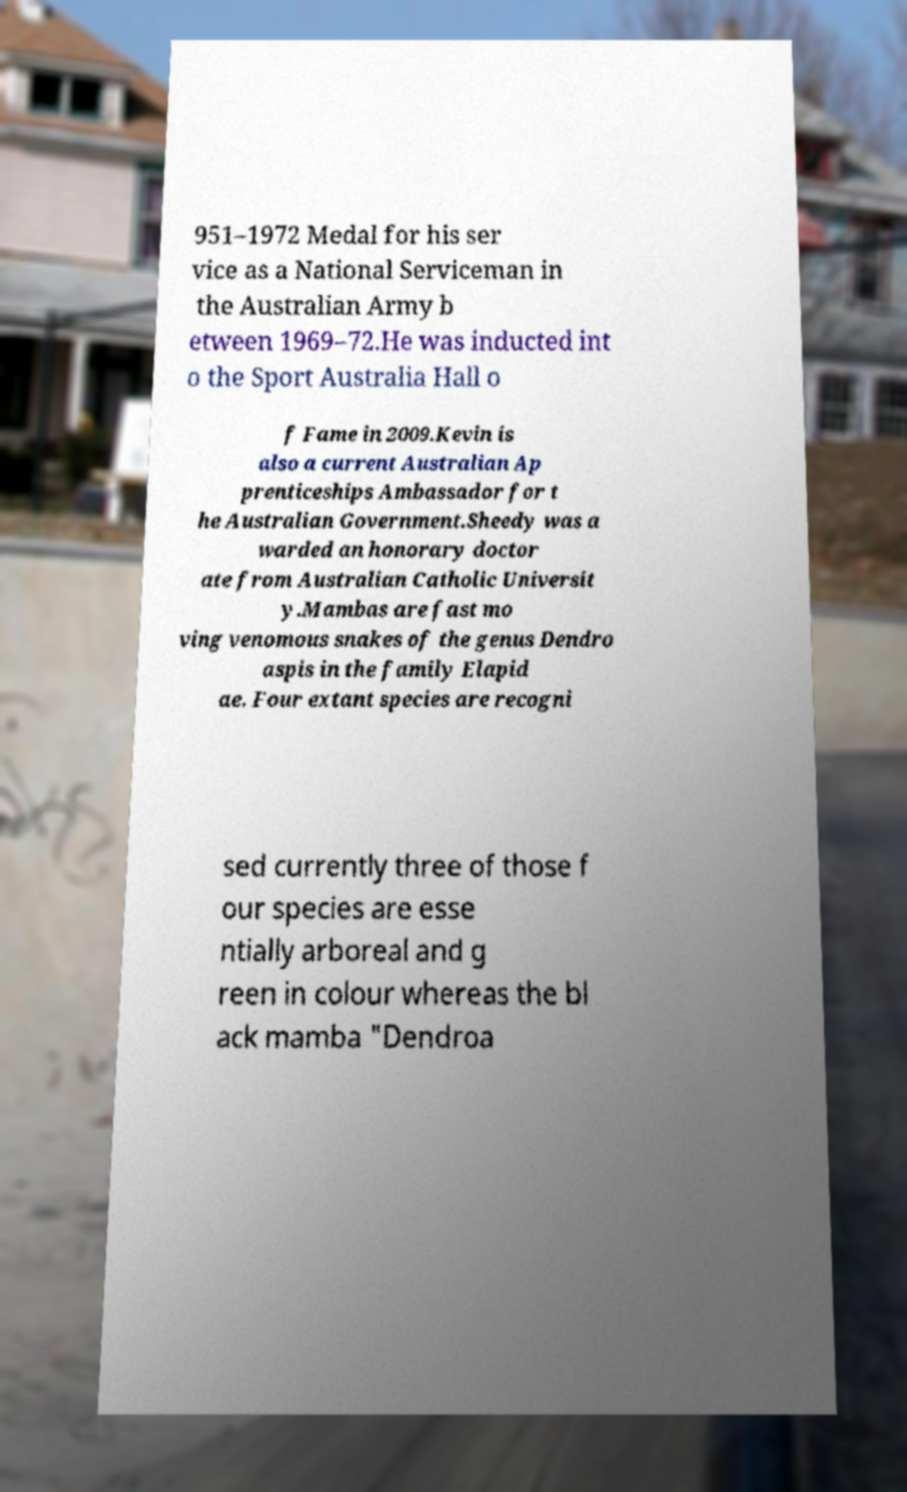Could you extract and type out the text from this image? 951–1972 Medal for his ser vice as a National Serviceman in the Australian Army b etween 1969–72.He was inducted int o the Sport Australia Hall o f Fame in 2009.Kevin is also a current Australian Ap prenticeships Ambassador for t he Australian Government.Sheedy was a warded an honorary doctor ate from Australian Catholic Universit y.Mambas are fast mo ving venomous snakes of the genus Dendro aspis in the family Elapid ae. Four extant species are recogni sed currently three of those f our species are esse ntially arboreal and g reen in colour whereas the bl ack mamba "Dendroa 